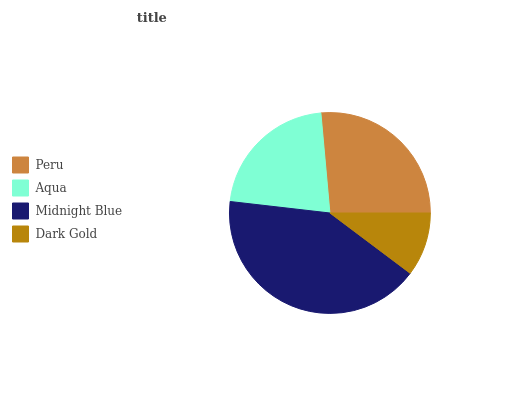Is Dark Gold the minimum?
Answer yes or no. Yes. Is Midnight Blue the maximum?
Answer yes or no. Yes. Is Aqua the minimum?
Answer yes or no. No. Is Aqua the maximum?
Answer yes or no. No. Is Peru greater than Aqua?
Answer yes or no. Yes. Is Aqua less than Peru?
Answer yes or no. Yes. Is Aqua greater than Peru?
Answer yes or no. No. Is Peru less than Aqua?
Answer yes or no. No. Is Peru the high median?
Answer yes or no. Yes. Is Aqua the low median?
Answer yes or no. Yes. Is Midnight Blue the high median?
Answer yes or no. No. Is Dark Gold the low median?
Answer yes or no. No. 